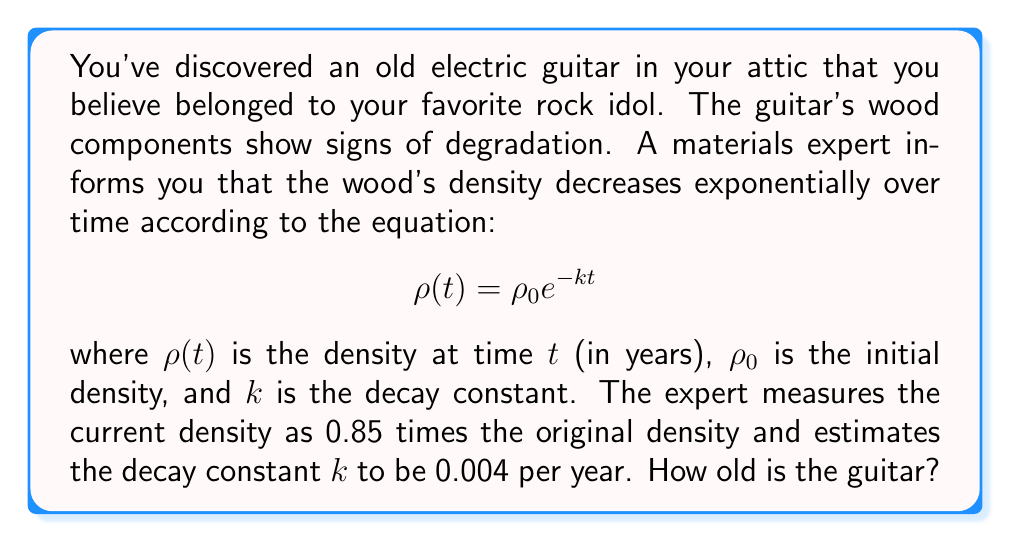Can you solve this math problem? Let's approach this step-by-step:

1) We're given the equation for exponential decay:
   $$\rho(t) = \rho_0 e^{-kt}$$

2) We know that the current density is 0.85 times the original density:
   $$\frac{\rho(t)}{\rho_0} = 0.85$$

3) Substituting this into our original equation:
   $$0.85 = e^{-kt}$$

4) We're also given that $k = 0.004$ per year. Now we need to solve for $t$.

5) Taking the natural logarithm of both sides:
   $$\ln(0.85) = -0.004t$$

6) Dividing both sides by -0.004:
   $$\frac{\ln(0.85)}{-0.004} = t$$

7) Calculate:
   $$t = \frac{\ln(0.85)}{-0.004} \approx 40.55$$

Therefore, the guitar is approximately 40.55 years old.
Answer: 40.55 years 